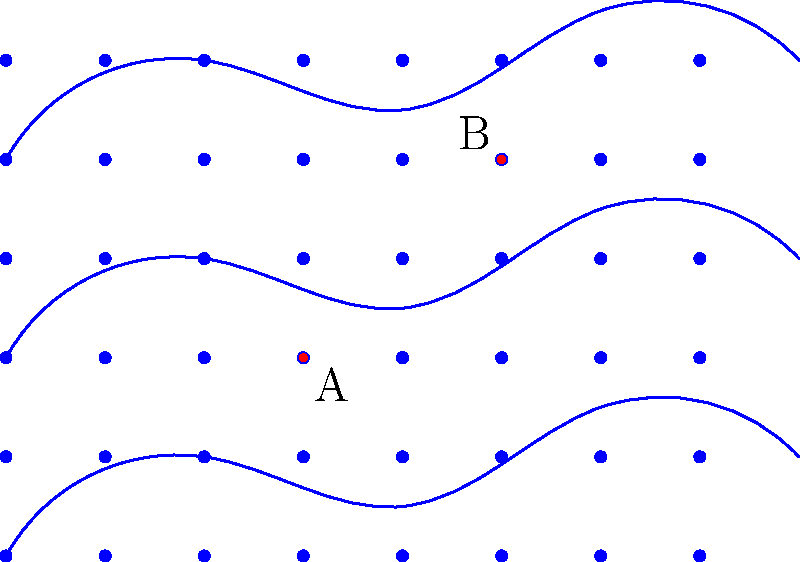Based on the land contour map and rainfall pattern shown, where should two water collection points (A and B) be strategically placed to maximize water harvesting efficiency for an eco-friendly water management system? Explain the rationale behind your choice and calculate the potential water collection volume for each point, assuming an average annual rainfall of 1000 mm and a collection efficiency of 80%. To answer this question, we need to analyze the land contours and rainfall pattern, and then calculate the potential water collection volume for the given points. Let's break it down step-by-step:

1. Analyzing the land contours and rainfall pattern:
   - The blue lines represent land contours, with higher elevations towards the top of the image.
   - The blue dots represent the rainfall pattern, which appears to be uniform across the area.
   - Points A and B are marked in red on the map.

2. Rationale for point placement:
   - Point A (30,20) is located in a small depression between two contour lines, which is ideal for water collection.
   - Point B (50,40) is positioned at a higher elevation, capturing runoff from the surrounding higher areas.

3. Calculating potential water collection volume:
   Let's assume each point can collect water from a 100 m² area (10m x 10m).

   For each point:
   - Annual rainfall = 1000 mm = 1 m
   - Collection area = 100 m²
   - Collection efficiency = 80% = 0.8

   Volume calculation:
   $V = \text{Rainfall} \times \text{Area} \times \text{Efficiency}$
   $V = 1 \text{ m} \times 100 \text{ m}^2 \times 0.8 = 80 \text{ m}^3$

   Therefore, each point can potentially collect 80 m³ of water annually.

4. Total potential water collection:
   $V_{\text{total}} = V_A + V_B = 80 \text{ m}^3 + 80 \text{ m}^3 = 160 \text{ m}^3$

This placement strategy maximizes water harvesting efficiency by utilizing natural depressions and elevation differences to collect both direct rainfall and runoff from surrounding areas.
Answer: Points A (30,20) and B (50,40); Each point can collect 80 m³ annually, totaling 160 m³. 